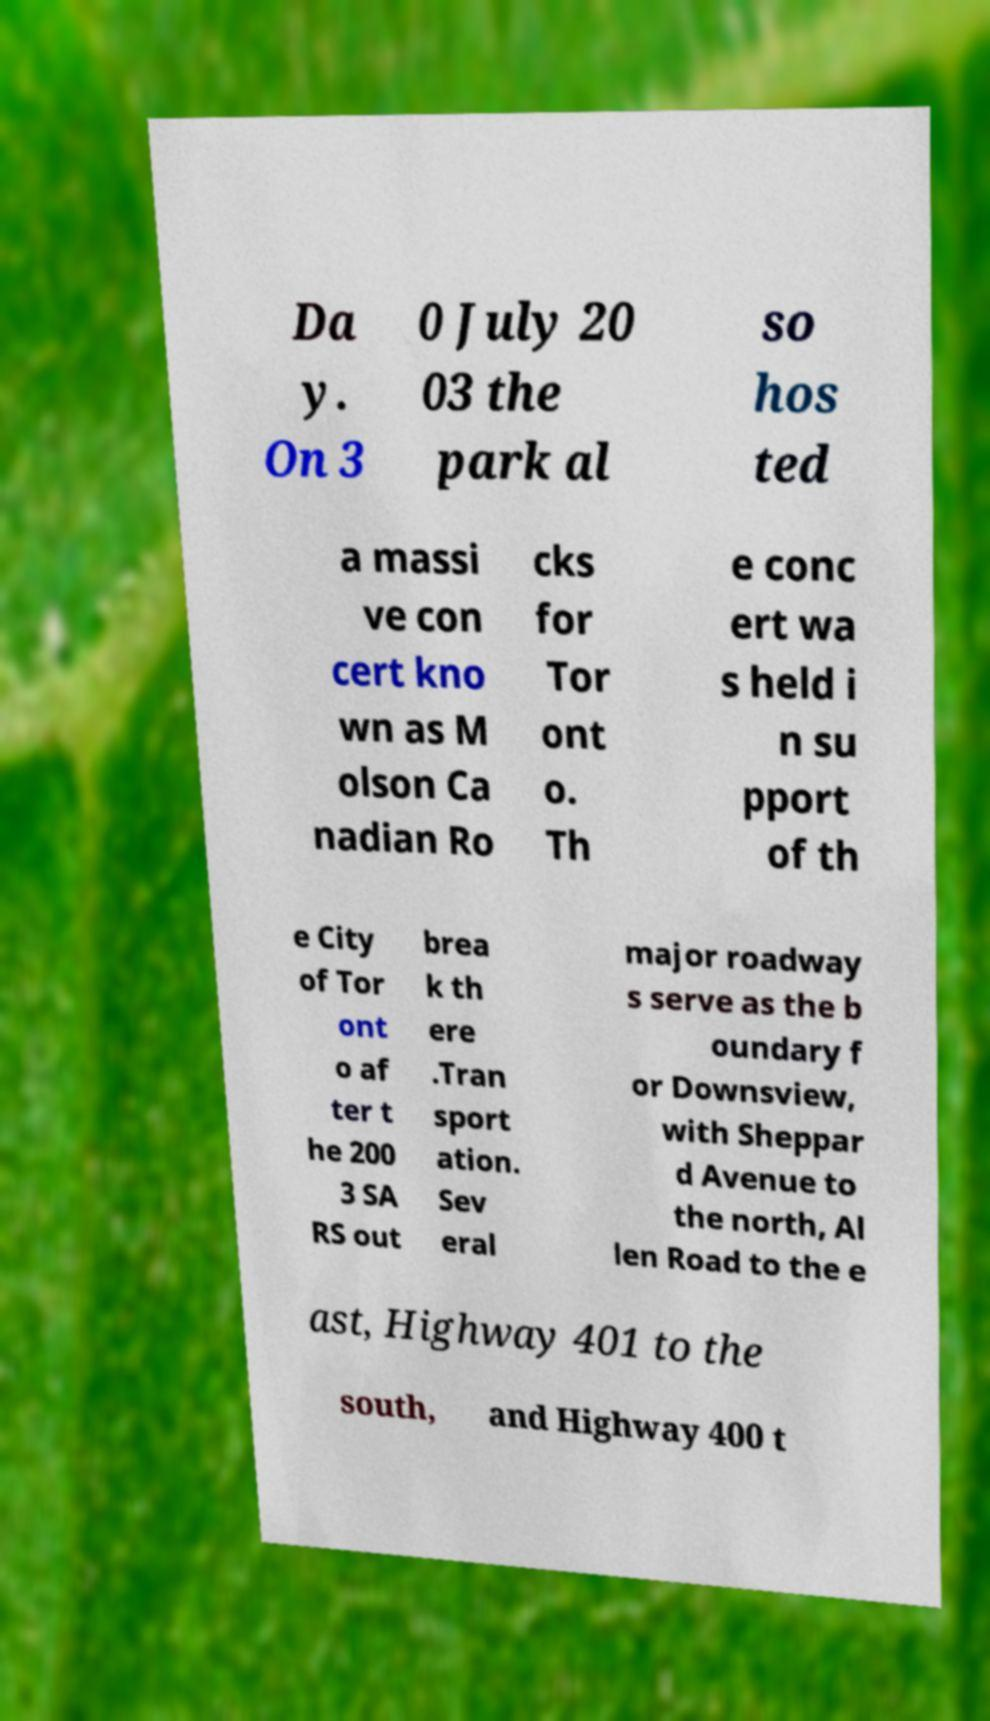For documentation purposes, I need the text within this image transcribed. Could you provide that? Da y. On 3 0 July 20 03 the park al so hos ted a massi ve con cert kno wn as M olson Ca nadian Ro cks for Tor ont o. Th e conc ert wa s held i n su pport of th e City of Tor ont o af ter t he 200 3 SA RS out brea k th ere .Tran sport ation. Sev eral major roadway s serve as the b oundary f or Downsview, with Sheppar d Avenue to the north, Al len Road to the e ast, Highway 401 to the south, and Highway 400 t 